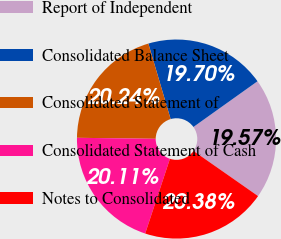Convert chart. <chart><loc_0><loc_0><loc_500><loc_500><pie_chart><fcel>Report of Independent<fcel>Consolidated Balance Sheet<fcel>Consolidated Statement of<fcel>Consolidated Statement of Cash<fcel>Notes to Consolidated<nl><fcel>19.57%<fcel>19.7%<fcel>20.24%<fcel>20.11%<fcel>20.38%<nl></chart> 